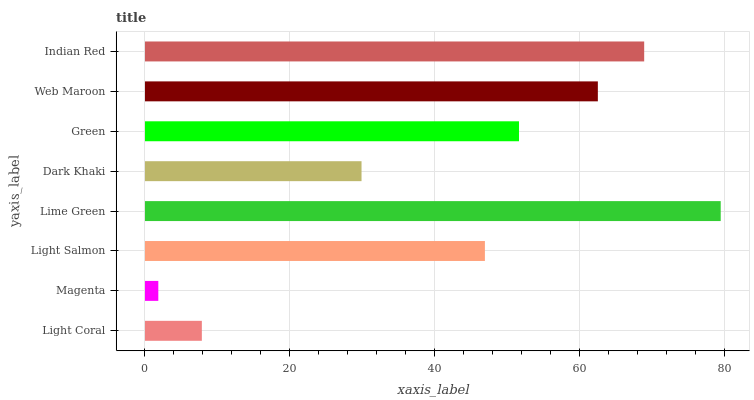Is Magenta the minimum?
Answer yes or no. Yes. Is Lime Green the maximum?
Answer yes or no. Yes. Is Light Salmon the minimum?
Answer yes or no. No. Is Light Salmon the maximum?
Answer yes or no. No. Is Light Salmon greater than Magenta?
Answer yes or no. Yes. Is Magenta less than Light Salmon?
Answer yes or no. Yes. Is Magenta greater than Light Salmon?
Answer yes or no. No. Is Light Salmon less than Magenta?
Answer yes or no. No. Is Green the high median?
Answer yes or no. Yes. Is Light Salmon the low median?
Answer yes or no. Yes. Is Dark Khaki the high median?
Answer yes or no. No. Is Green the low median?
Answer yes or no. No. 